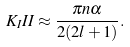Convert formula to latex. <formula><loc_0><loc_0><loc_500><loc_500>K _ { I } I I \approx \frac { \pi n \alpha } { 2 ( 2 l + 1 ) } .</formula> 